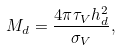<formula> <loc_0><loc_0><loc_500><loc_500>M _ { d } = \frac { 4 \pi \tau _ { V } h _ { d } ^ { 2 } } { \sigma _ { V } } ,</formula> 